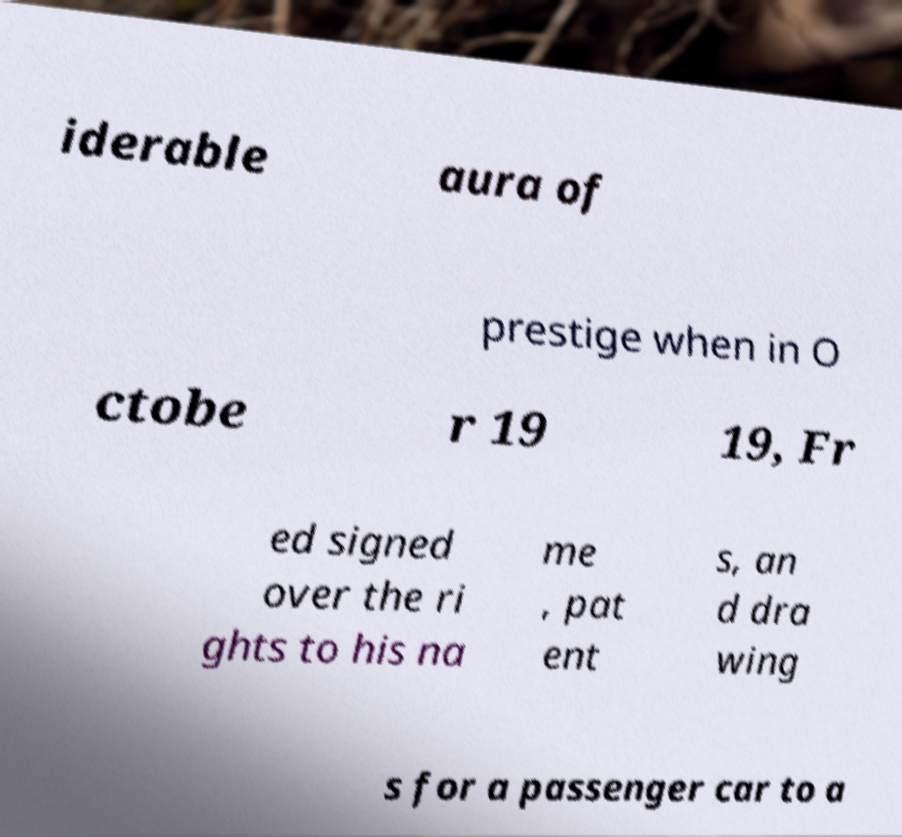Please read and relay the text visible in this image. What does it say? iderable aura of prestige when in O ctobe r 19 19, Fr ed signed over the ri ghts to his na me , pat ent s, an d dra wing s for a passenger car to a 